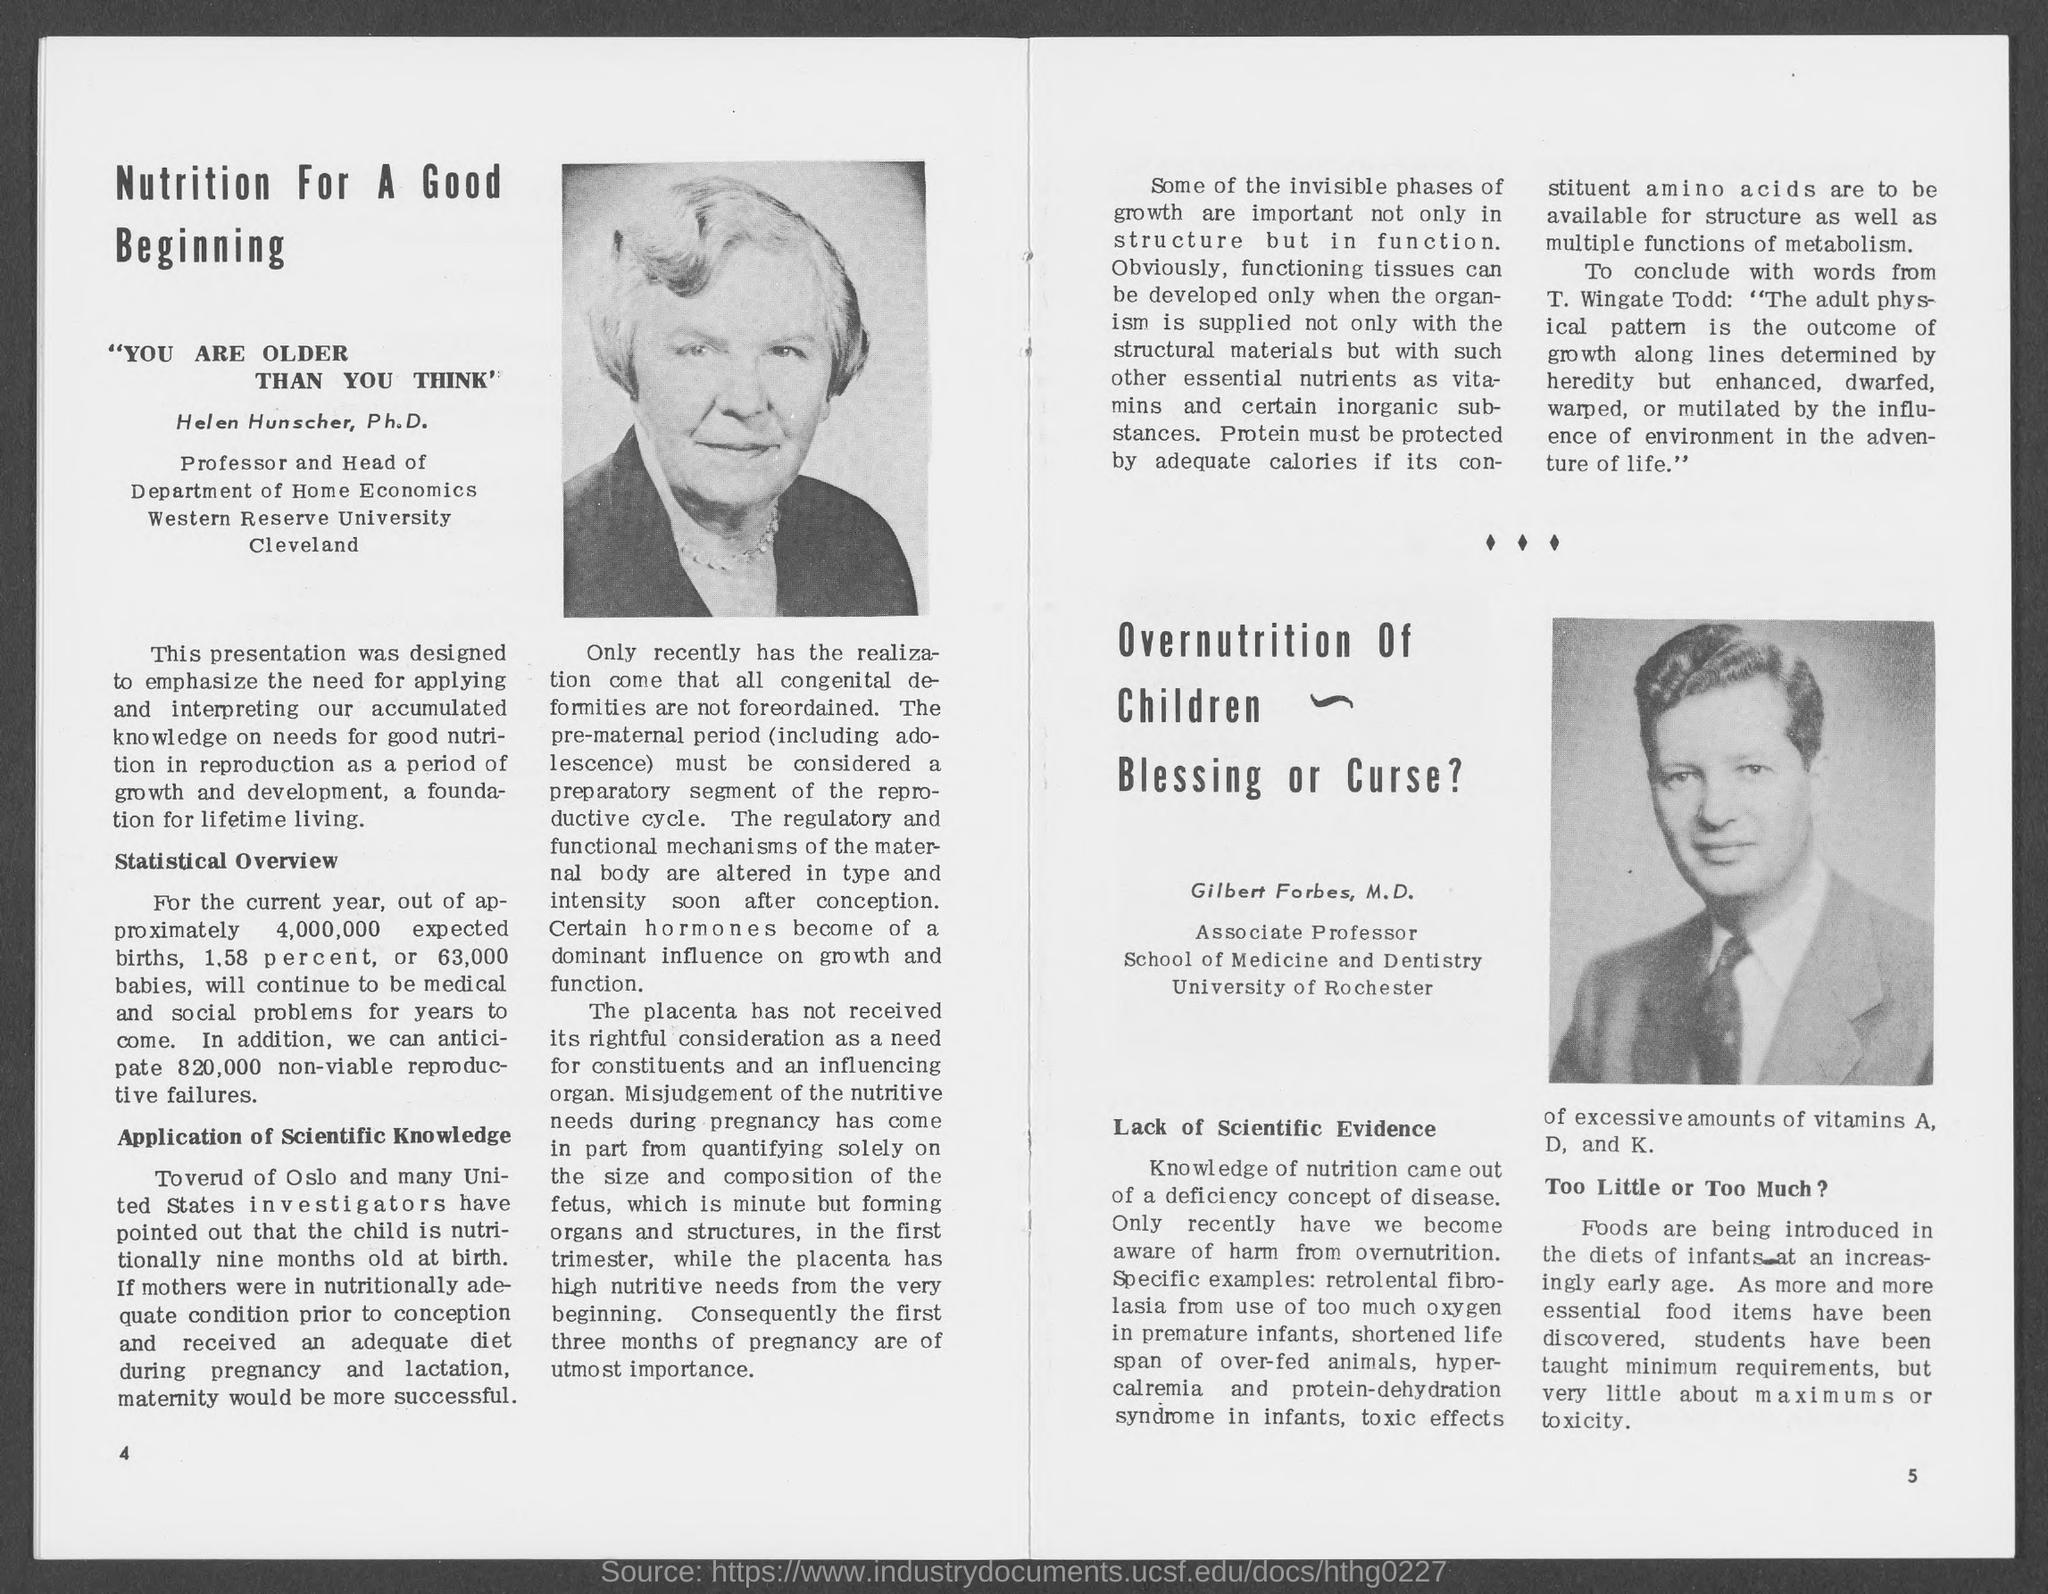What is the heading on the left hand side of the document?
Your answer should be very brief. Nutrition for a good beginning. What is the name of the lady in the photo?
Provide a short and direct response. Helen Hunscher, Ph.D. In which department does helen work?
Your answer should be very brief. Department of Home Economics. In which university is helen from?
Make the answer very short. Western Reserve University. Where is western reserve university?
Provide a succinct answer. Cleveland. What is the name of the man in the photo?
Your response must be concise. Gilbert. Which university is gilbert from?
Provide a succinct answer. University of Rochester. What percent of babies of expected births will "continue to be social or medical problems?
Your response must be concise. 1.58. What is altered in the maternal body soon after conception?
Offer a very short reply. The regulatory and functional mechanisms. 